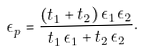<formula> <loc_0><loc_0><loc_500><loc_500>\epsilon _ { p } = \frac { ( t _ { 1 } + t _ { 2 } ) \, \epsilon _ { 1 } \, \epsilon _ { 2 } } { t _ { 1 } \, \epsilon _ { 1 } + t _ { 2 } \, \epsilon _ { 2 } } .</formula> 